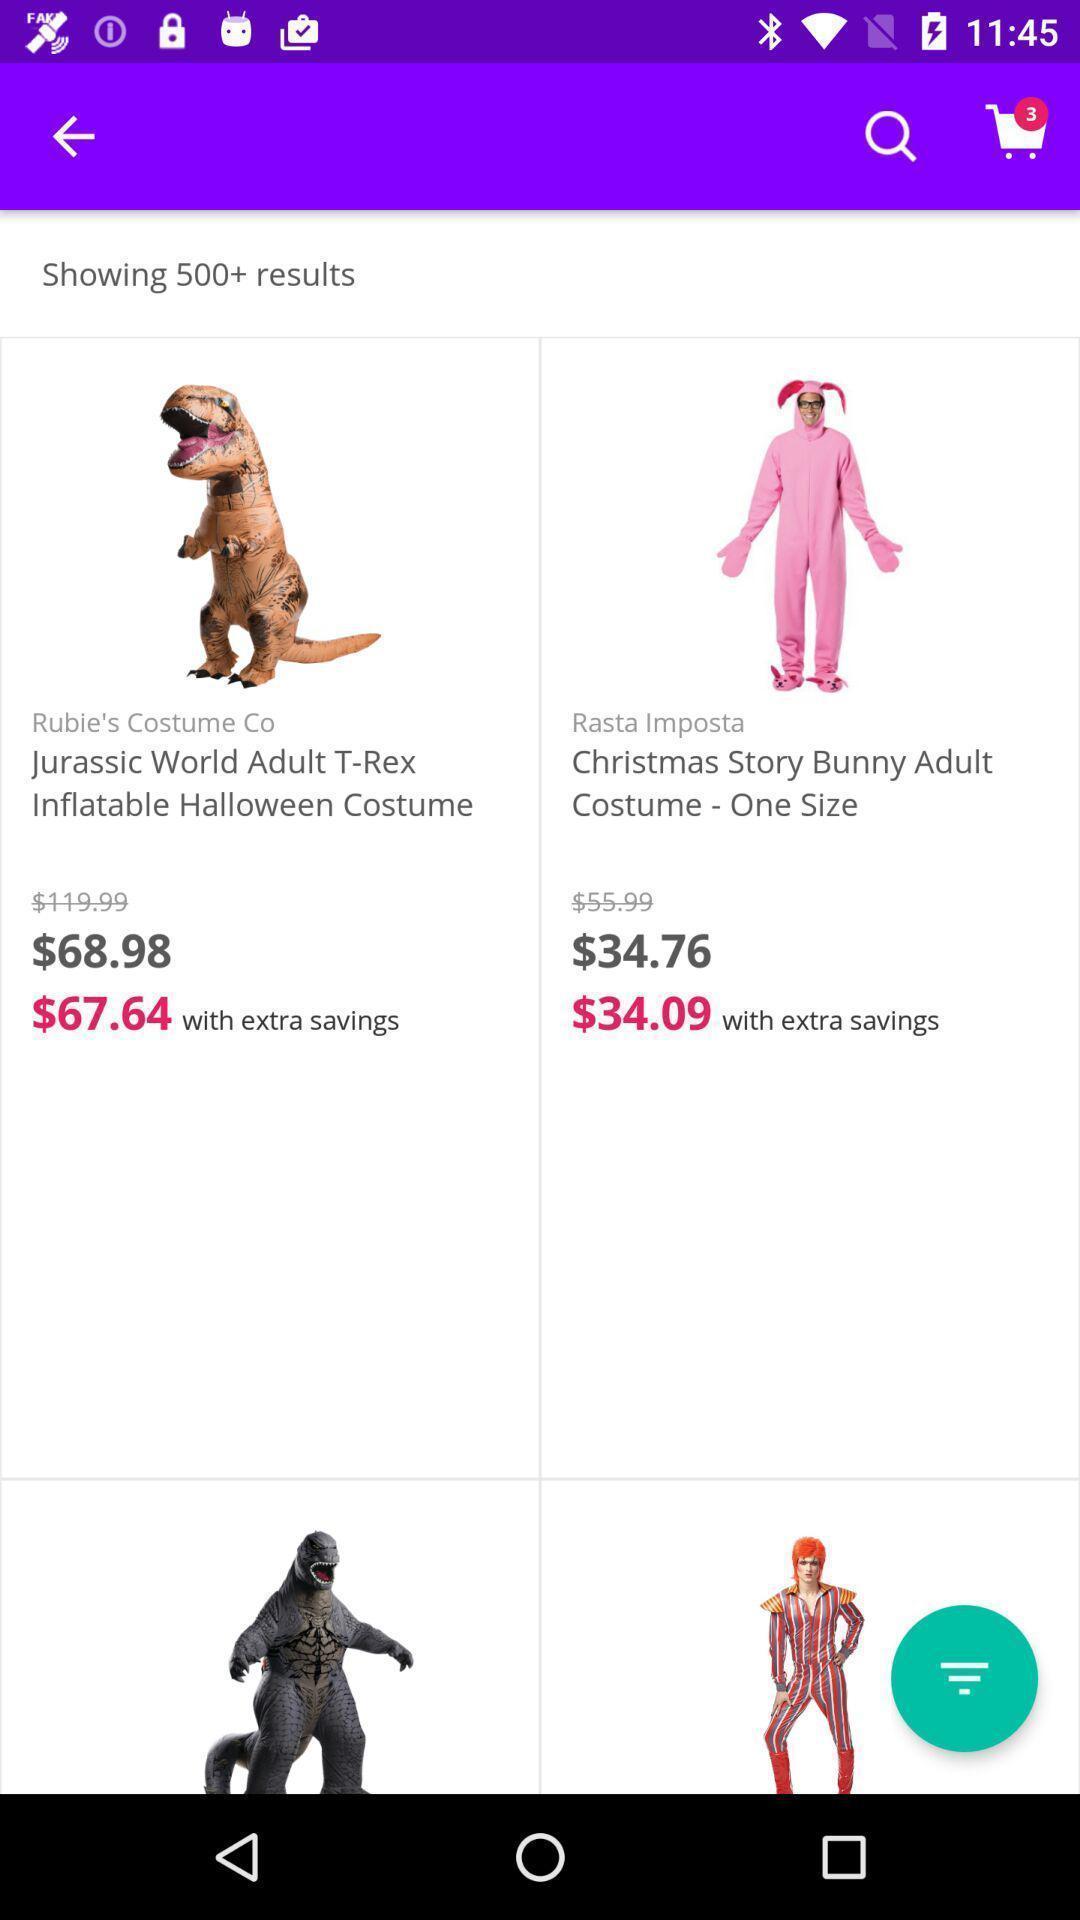Summarize the main components in this picture. Screen displaying multiple costumes with price in a shopping application. 